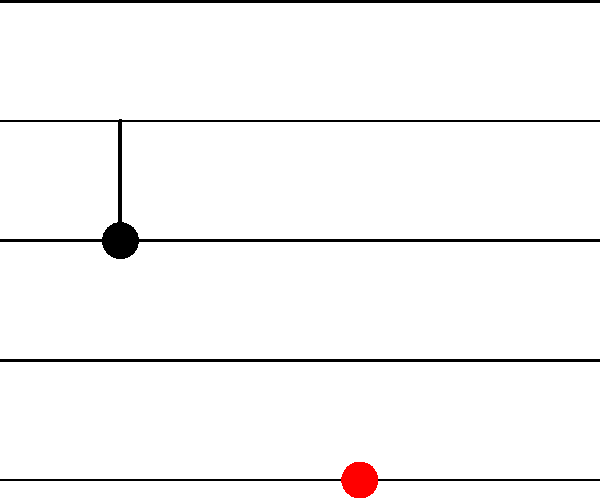You're working on a new track and want to add some visual flair to the sheet music. If you rotate a quarter note $90^\circ$ clockwise around the point $(3, 2)$ on the staff, where will the center of the note head end up? Give your answer as an ordered pair $(x, y)$. Let's break this down step-by-step:

1) The original quarter note is positioned at $(1, 2)$ on the staff.

2) We're rotating around the point $(3, 2)$, which acts as our center of rotation.

3) A $90^\circ$ clockwise rotation is equivalent to a $90^\circ$ counterclockwise rotation in the coordinate plane.

4) To perform this rotation, we can use the rotation formula:
   $x' = (x - x_c)\cos\theta - (y - y_c)\sin\theta + x_c$
   $y' = (x - x_c)\sin\theta + (y - y_c)\cos\theta + y_c$
   
   Where $(x, y)$ is the original point, $(x_c, y_c)$ is the center of rotation, and $\theta$ is the angle of rotation.

5) In this case:
   $(x, y) = (1, 2)$
   $(x_c, y_c) = (3, 2)$
   $\theta = 90^\circ = \frac{\pi}{2}$ radians

6) Substituting these values:
   $x' = (1 - 3)\cos(\frac{\pi}{2}) - (2 - 2)\sin(\frac{\pi}{2}) + 3 = -2 \cdot 0 - 0 \cdot 1 + 3 = 3$
   $y' = (1 - 3)\sin(\frac{\pi}{2}) + (2 - 2)\cos(\frac{\pi}{2}) + 2 = -2 \cdot 1 + 0 \cdot 0 + 2 = 0$

7) Therefore, after rotation, the center of the note head will be at $(3, 0)$.
Answer: $(3, 0)$ 